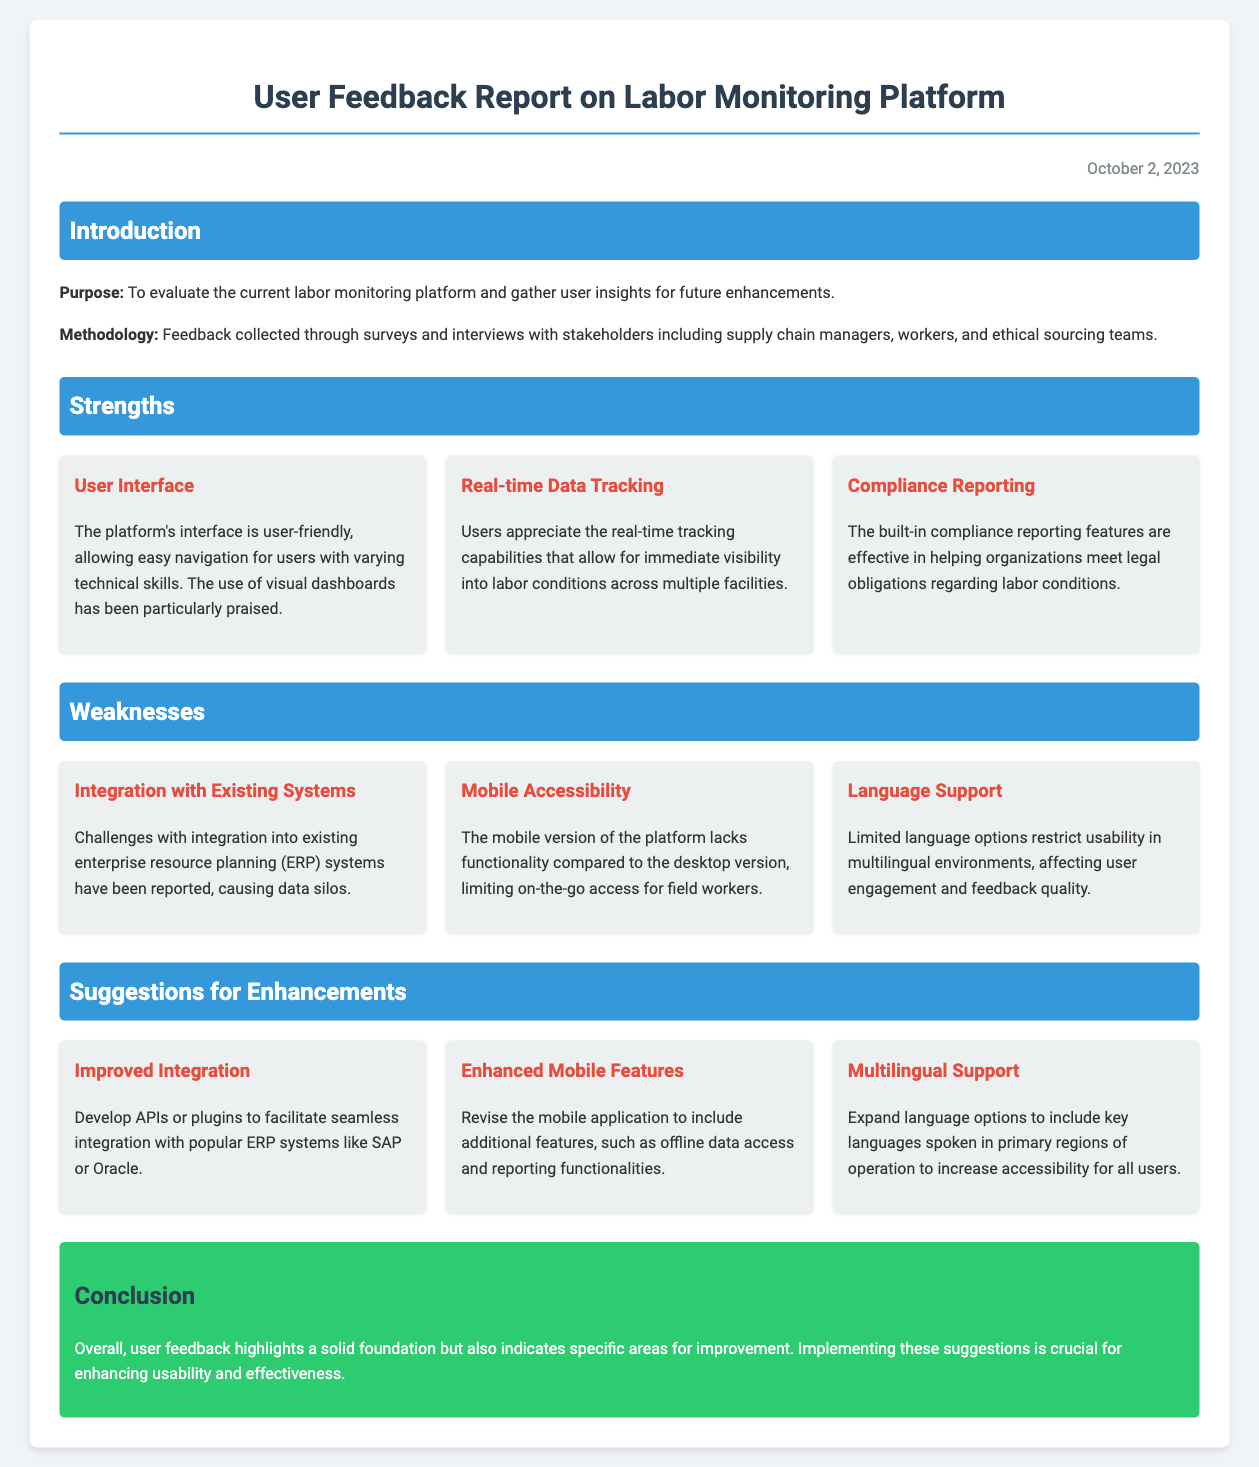what is the purpose of the report? The purpose of the report is stated as evaluating the current labor monitoring platform and gathering user insights for future enhancements.
Answer: evaluating the current labor monitoring platform and gathering user insights for future enhancements when was the report published? The date of publication is mentioned in the document.
Answer: October 2, 2023 what is one strength of the user interface? The document highlights that the user interface is user-friendly, allowing easy navigation for users with varying technical skills.
Answer: user-friendly what is a reported weakness related to mobile access? It mentions that the mobile version of the platform lacks functionality compared to the desktop version.
Answer: lacks functionality compared to the desktop version what is one suggestion for enhancing integration? The report suggests developing APIs or plugins to facilitate seamless integration with popular ERP systems.
Answer: develop APIs or plugins how many strengths are identified in the report? The document lists three distinct strengths under the strengths section.
Answer: three which stakeholders provided feedback for the report? It mentions that feedback was collected from several groups, including supply chain managers, workers, and ethical sourcing teams.
Answer: supply chain managers, workers, and ethical sourcing teams what is one weakness related to language support? The document states that limited language options restrict usability in multilingual environments.
Answer: limited language options what is the conclusion of the report? The conclusion emphasizes that user feedback highlights a solid foundation but also indicates specific areas for improvement.
Answer: solid foundation but also indicates specific areas for improvement 